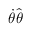Convert formula to latex. <formula><loc_0><loc_0><loc_500><loc_500>{ \dot { \theta } } { \hat { \theta } }</formula> 